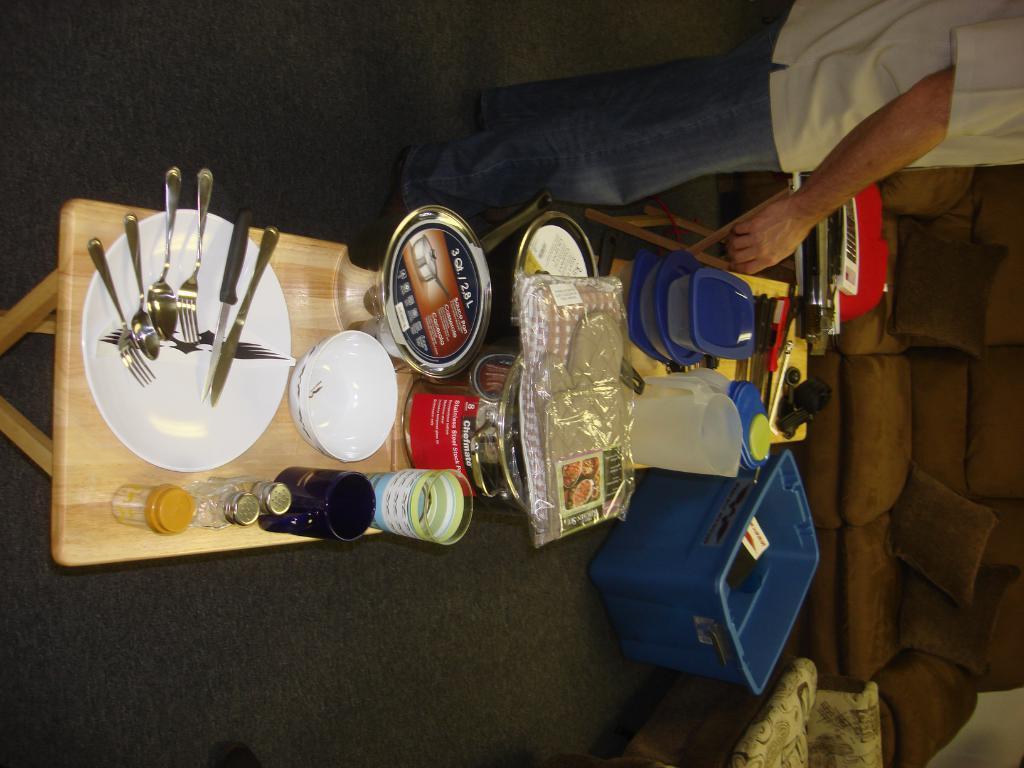In one or two sentences, can you explain what this image depicts? In this picture, we see a table on which plate containing spoons, forks and knives are placed. We even see cup, glass, glass jars, bowl and vessels are placed on the table. Beside that, we see a table on which plastic mug and plastic boxes are placed. Beside that, we see a blue color basket. The man in the white shirt is standing beside the table. In front of him, we see something in red color. On the right side, we see the sofa. At the bottom, we see the black carpet. 